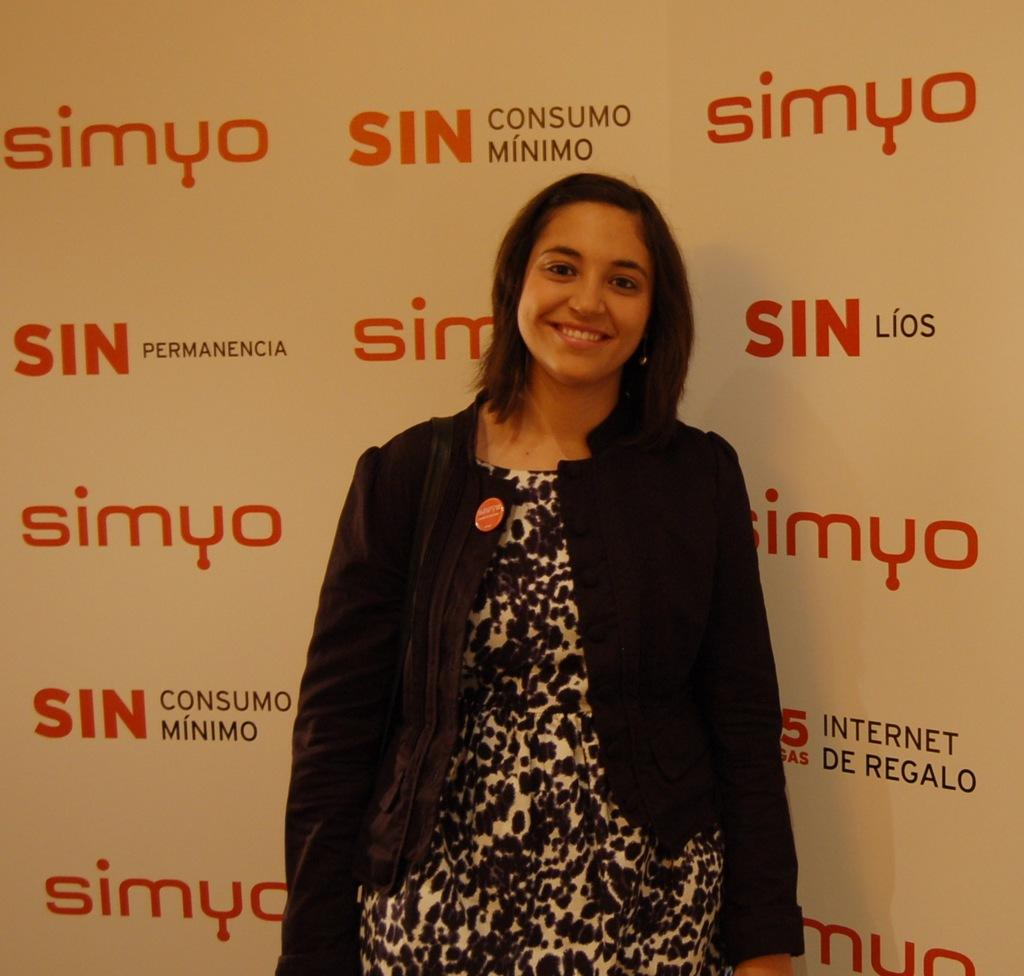What is the woman in the image doing? The woman is standing in the image. What is the woman wearing in the image? The woman is wearing a black coat in the image. What can be seen on the wall in the image? There is a banner on the wall in the image. What is written on the banner in the image? The banner has the word "Simyo" written on it. What type of punishment is the woman receiving in the image? There is no indication in the image that the woman is receiving any punishment. 